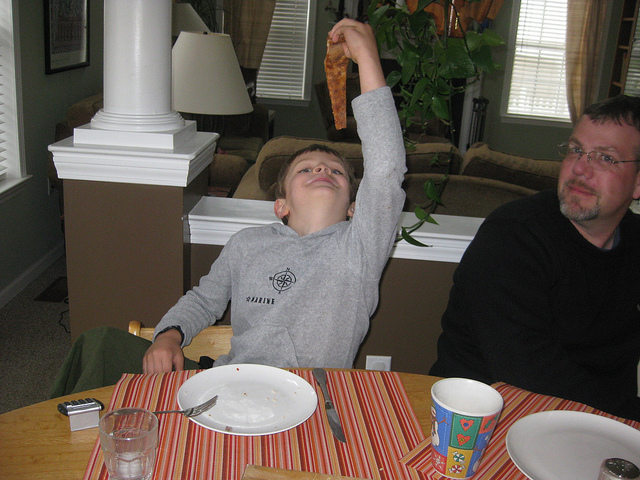Identify the text displayed in this image. CREATIVE 